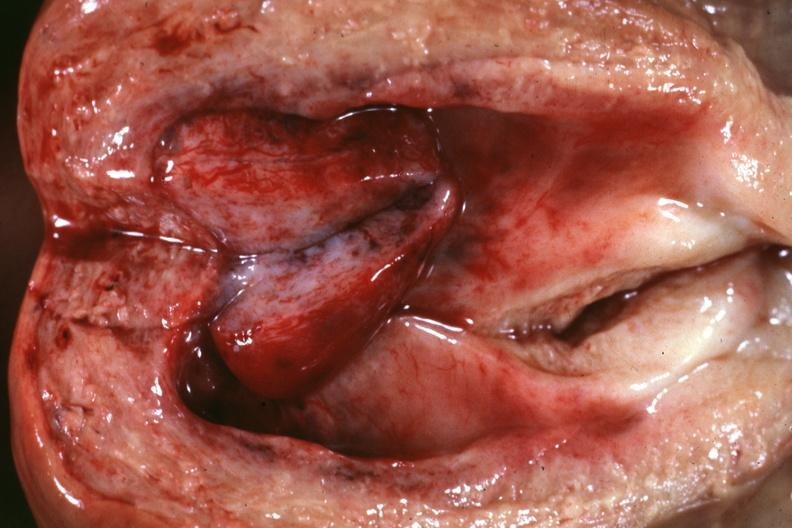does this image show opened uterus close-up with rather large polyp 66yo diabetic female no tissue diagnosis?
Answer the question using a single word or phrase. Yes 